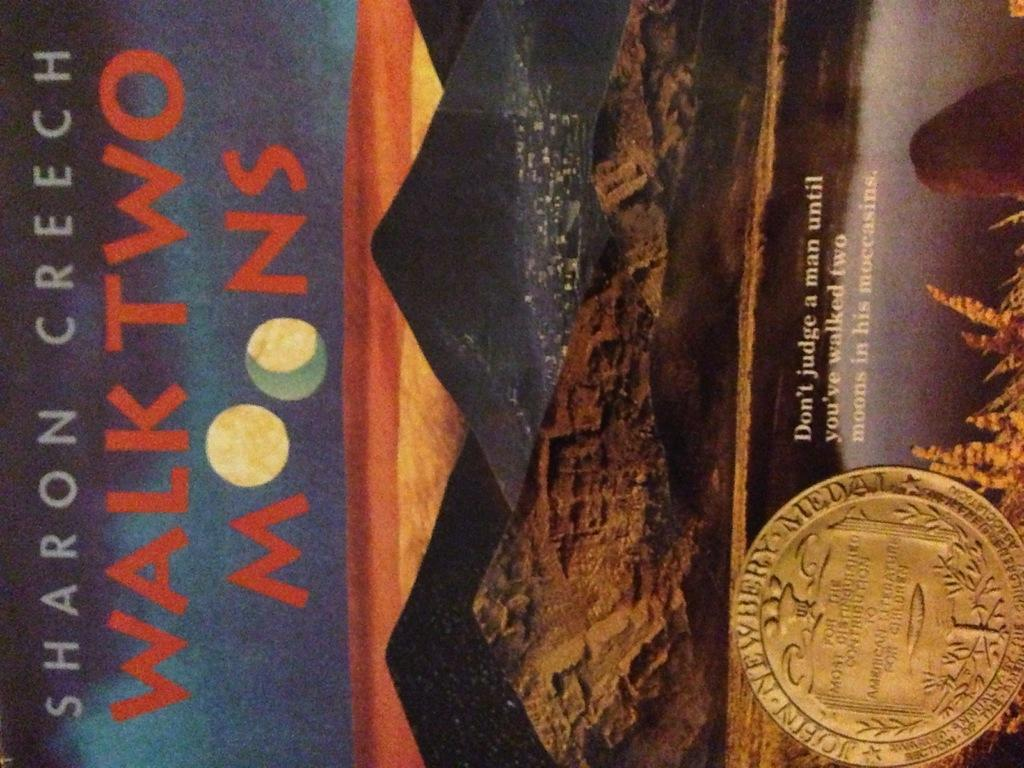<image>
Write a terse but informative summary of the picture. the cover photo of sharon creech's walk two moons book displayed with john newbery medal photo 